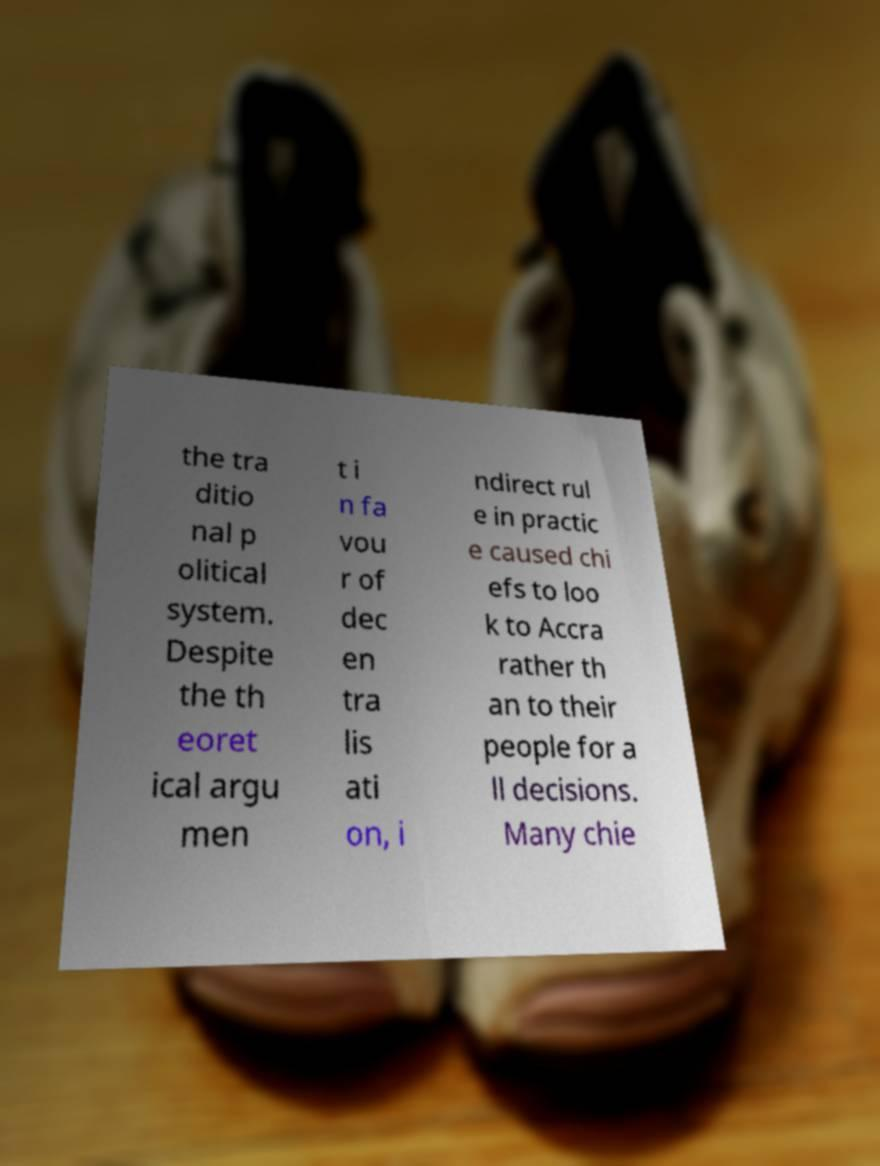Please identify and transcribe the text found in this image. the tra ditio nal p olitical system. Despite the th eoret ical argu men t i n fa vou r of dec en tra lis ati on, i ndirect rul e in practic e caused chi efs to loo k to Accra rather th an to their people for a ll decisions. Many chie 